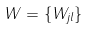Convert formula to latex. <formula><loc_0><loc_0><loc_500><loc_500>W = \{ W _ { j l } \}</formula> 